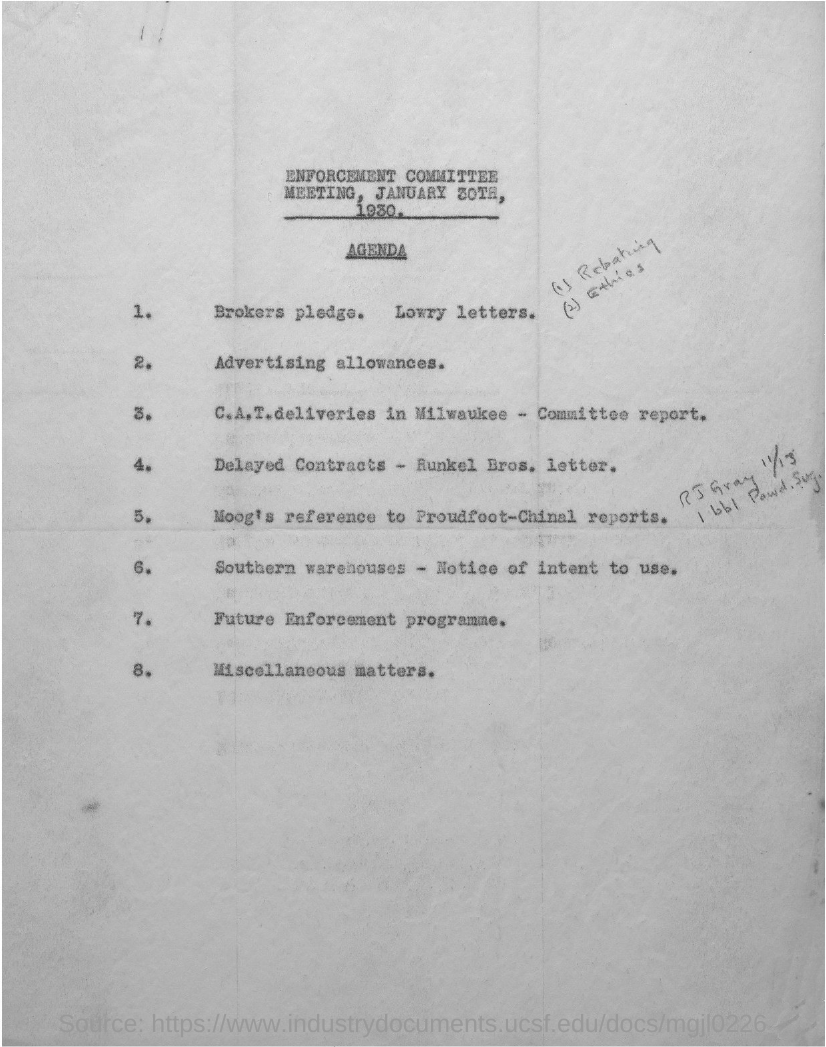What is the Agenda number 2?
Keep it short and to the point. Advertising allowances. What is the Agenda number 8?
Provide a succinct answer. Miscellaneous matters. 